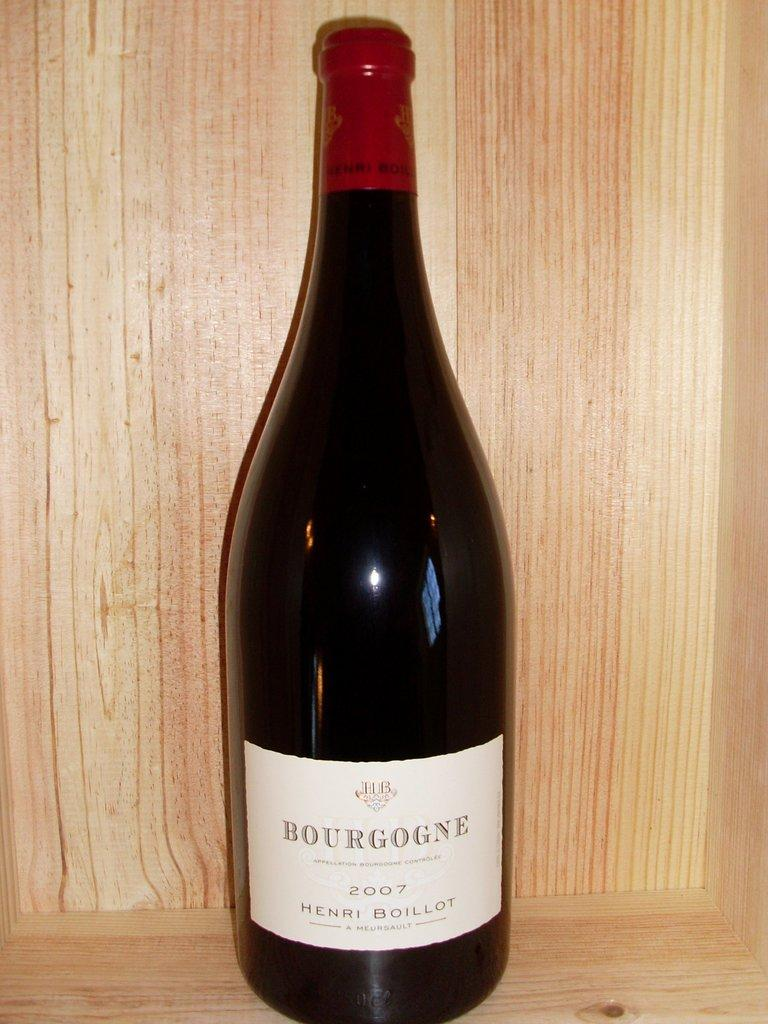<image>
Provide a brief description of the given image. A sealed bottle of Bourgogne 2007 Henri Boillot. 